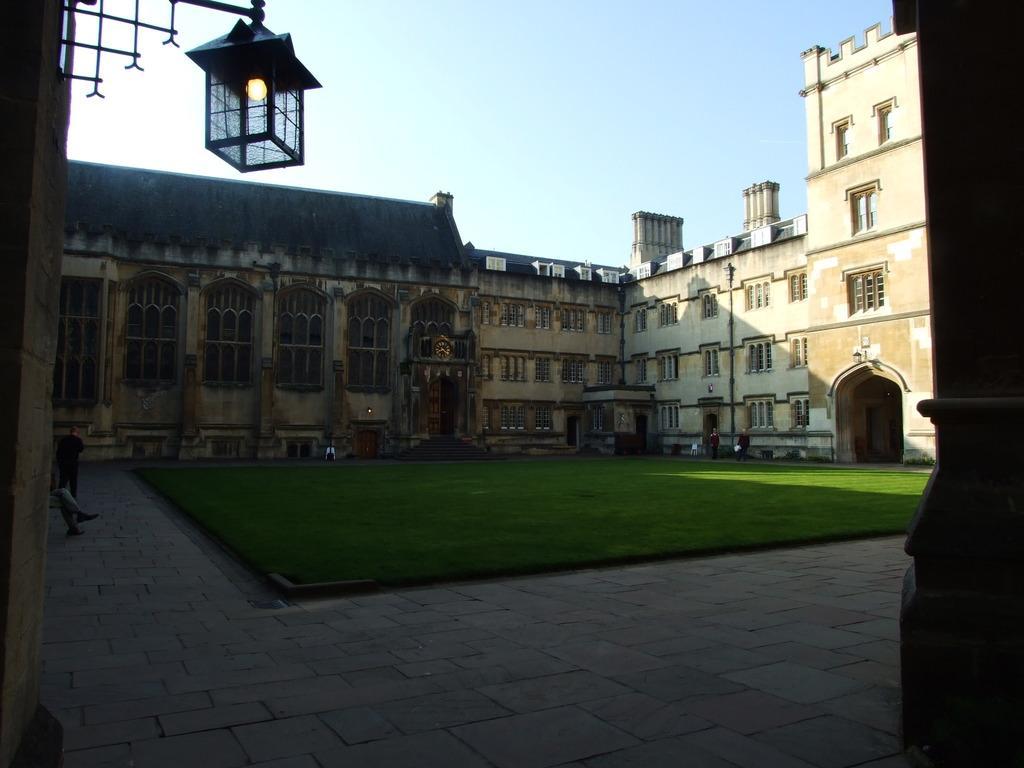Could you give a brief overview of what you see in this image? In this image in the center there is grass on the ground and in the background there are buildings. In the front on the top there is a light hanging. 